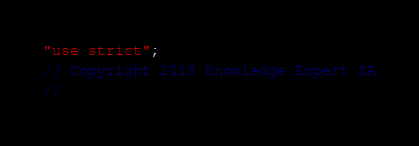<code> <loc_0><loc_0><loc_500><loc_500><_JavaScript_>"use strict";
// Copyright 2018 Knowledge Expert SA
//</code> 